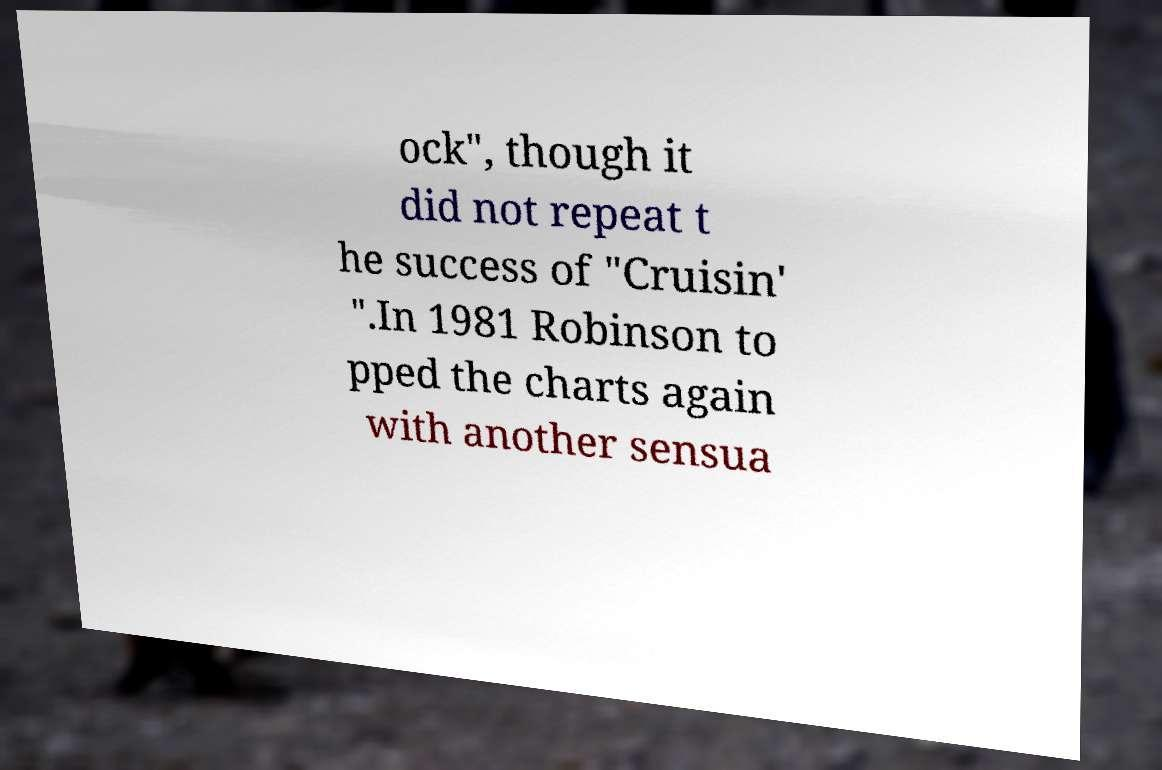What messages or text are displayed in this image? I need them in a readable, typed format. ock", though it did not repeat t he success of "Cruisin' ".In 1981 Robinson to pped the charts again with another sensua 